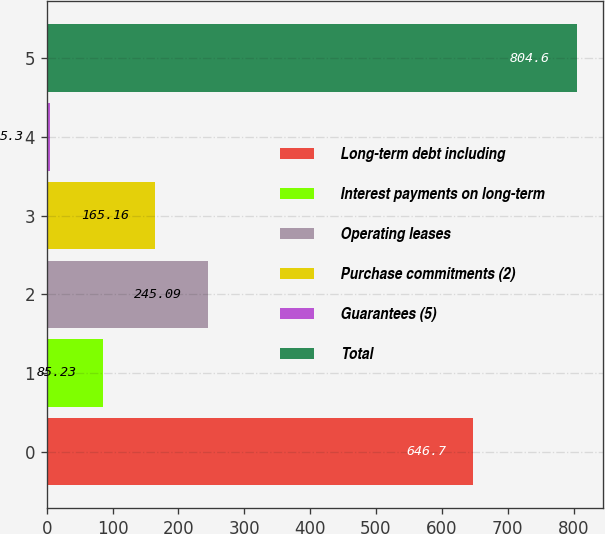Convert chart to OTSL. <chart><loc_0><loc_0><loc_500><loc_500><bar_chart><fcel>Long-term debt including<fcel>Interest payments on long-term<fcel>Operating leases<fcel>Purchase commitments (2)<fcel>Guarantees (5)<fcel>Total<nl><fcel>646.7<fcel>85.23<fcel>245.09<fcel>165.16<fcel>5.3<fcel>804.6<nl></chart> 